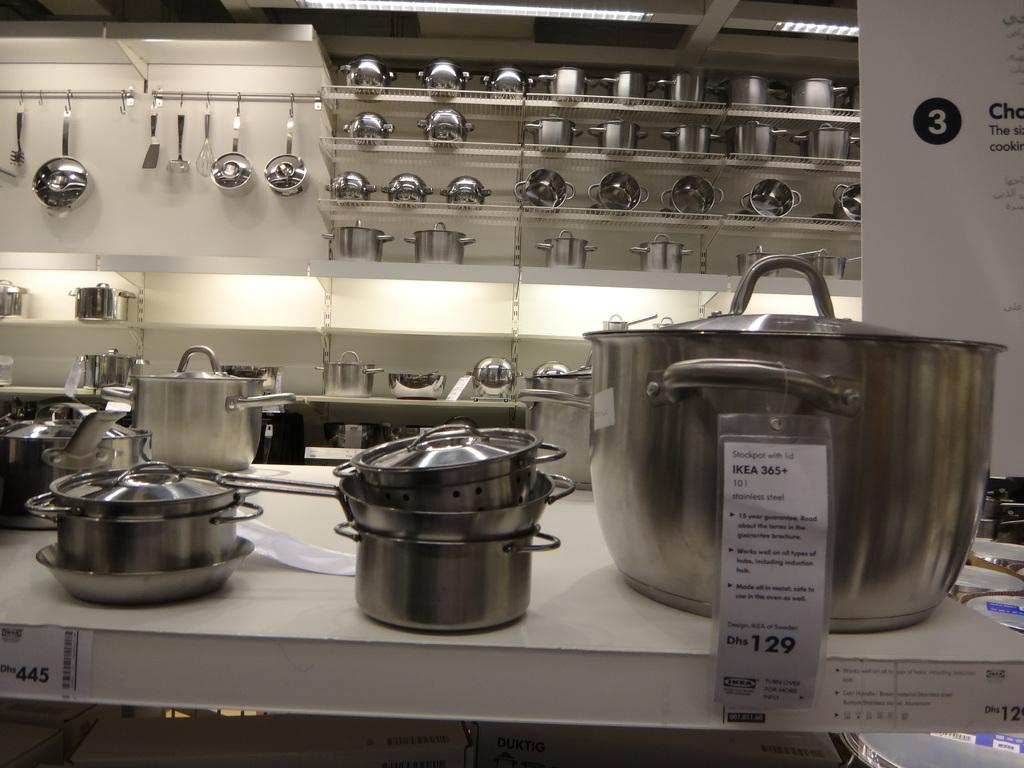<image>
Offer a succinct explanation of the picture presented. pots and pans on shelves in an Ikea store. 